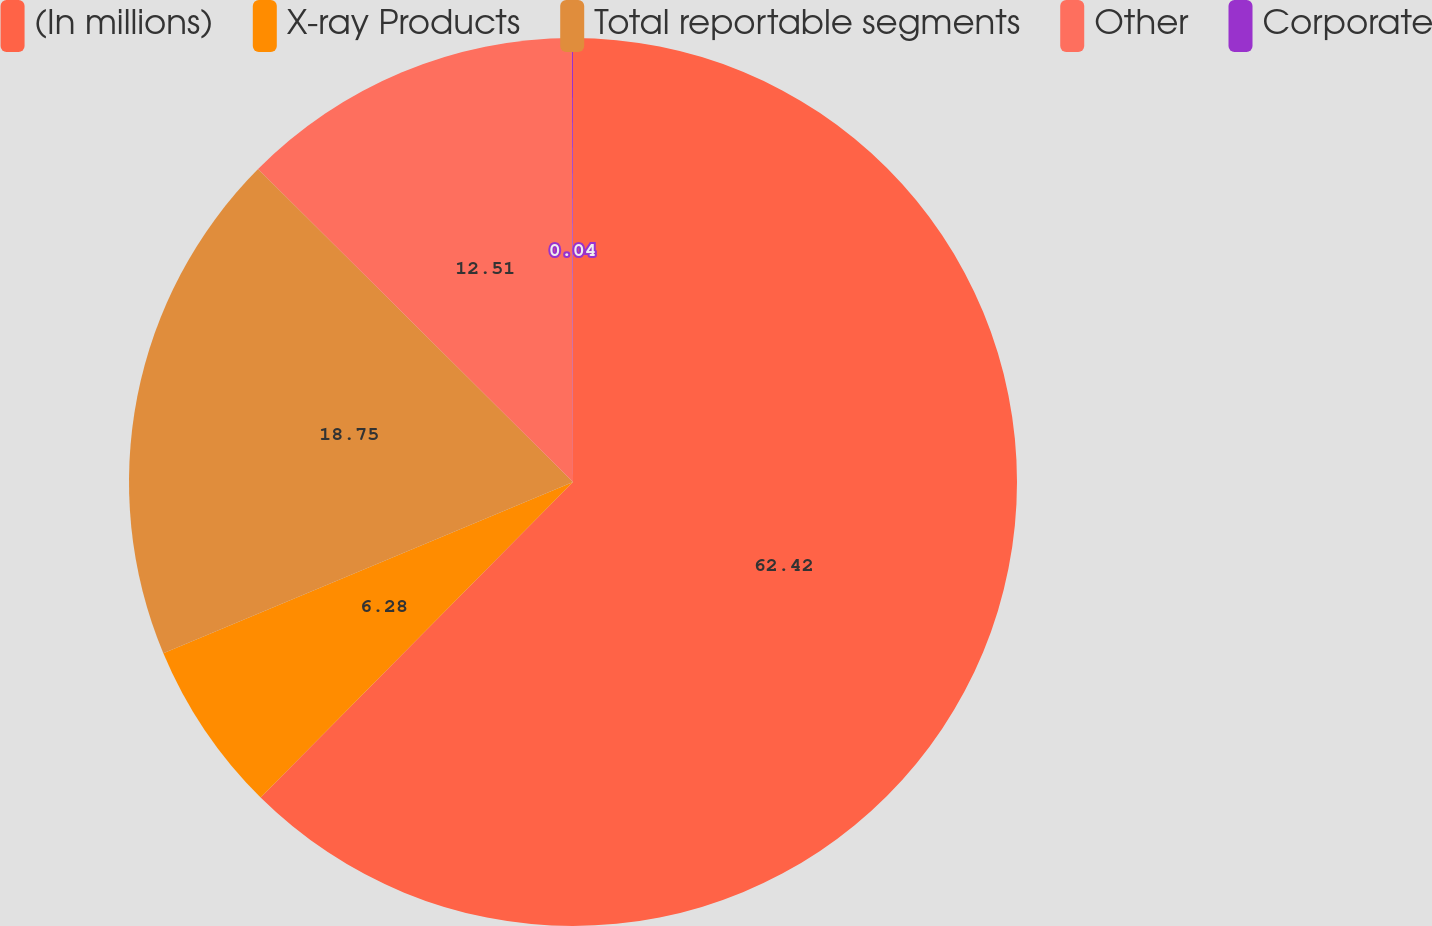<chart> <loc_0><loc_0><loc_500><loc_500><pie_chart><fcel>(In millions)<fcel>X-ray Products<fcel>Total reportable segments<fcel>Other<fcel>Corporate<nl><fcel>62.42%<fcel>6.28%<fcel>18.75%<fcel>12.51%<fcel>0.04%<nl></chart> 